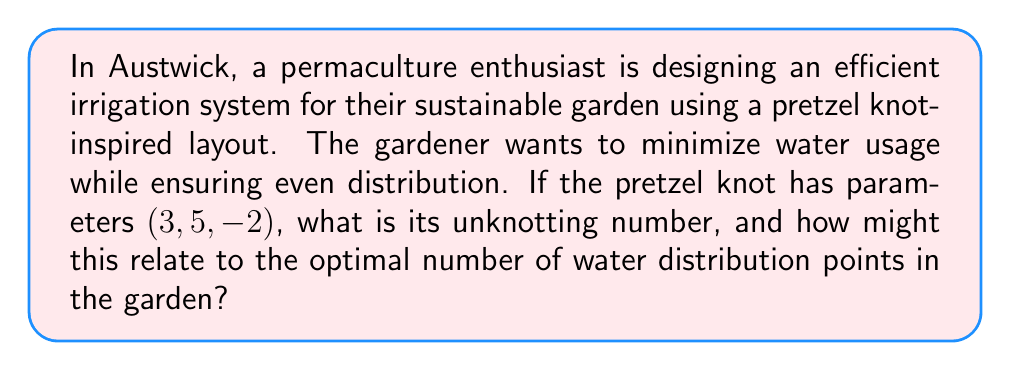Teach me how to tackle this problem. Let's approach this step-by-step:

1) A pretzel knot with parameters $(p, q, r)$ is denoted as $P(p, q, r)$. In this case, we have $P(3, 5, -2)$.

2) For pretzel knots, the unknotting number $u(K)$ is related to the parameters by the formula:

   $$u(K) = \min\{|p|, |q|, |r|, \frac{|p+q+r|-1}{2}\}$$

3) Substituting our values:

   $$u(K) = \min\{|3|, |5|, |-2|, \frac{|3+5+(-2)|-1}{2}\}$$

4) Simplify:

   $$u(K) = \min\{3, 5, 2, \frac{|6|-1}{2}\}$$

5) Calculate:

   $$u(K) = \min\{3, 5, 2, \frac{5}{2}\}$$

6) The minimum value is 2, so the unknotting number is 2.

7) In the context of irrigation, the unknotting number could represent the minimum number of key distribution points needed for efficient water distribution. Just as the unknotting number represents the least number of crossing changes needed to unknot the pretzel knot, it might correspond to the least number of strategic points needed to "unknot" or simplify the irrigation system while maintaining coverage.

8) Having 2 main distribution points in the garden could allow for a balanced and efficient irrigation system, mimicking the symmetry often found in pretzel knots. This could help in creating zones of similar water requirements, promoting sustainable water usage in line with permaculture principles.
Answer: 2 